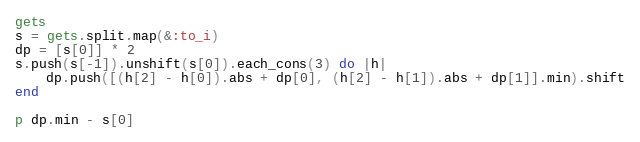Convert code to text. <code><loc_0><loc_0><loc_500><loc_500><_Ruby_>gets
s = gets.split.map(&:to_i)
dp = [s[0]] * 2
s.push(s[-1]).unshift(s[0]).each_cons(3) do |h| 
    dp.push([(h[2] - h[0]).abs + dp[0], (h[2] - h[1]).abs + dp[1]].min).shift
end

p dp.min - s[0]
</code> 